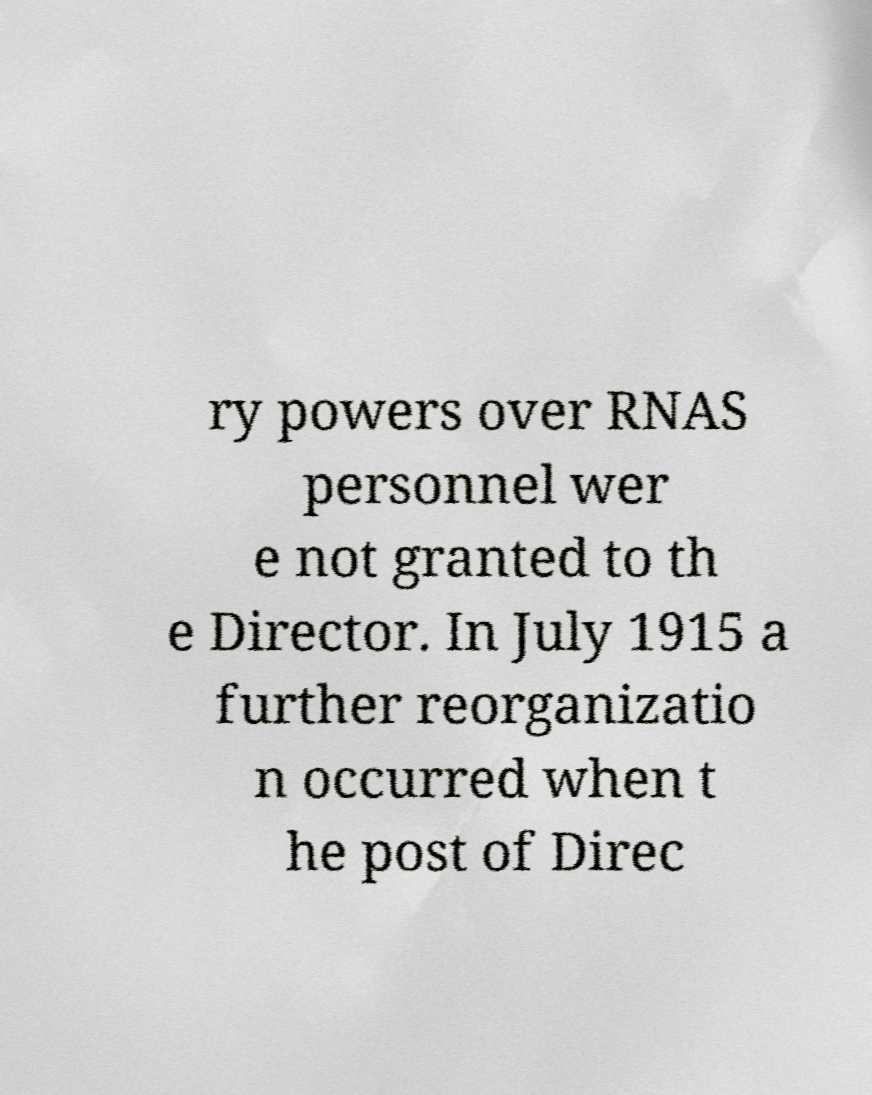Could you assist in decoding the text presented in this image and type it out clearly? ry powers over RNAS personnel wer e not granted to th e Director. In July 1915 a further reorganizatio n occurred when t he post of Direc 